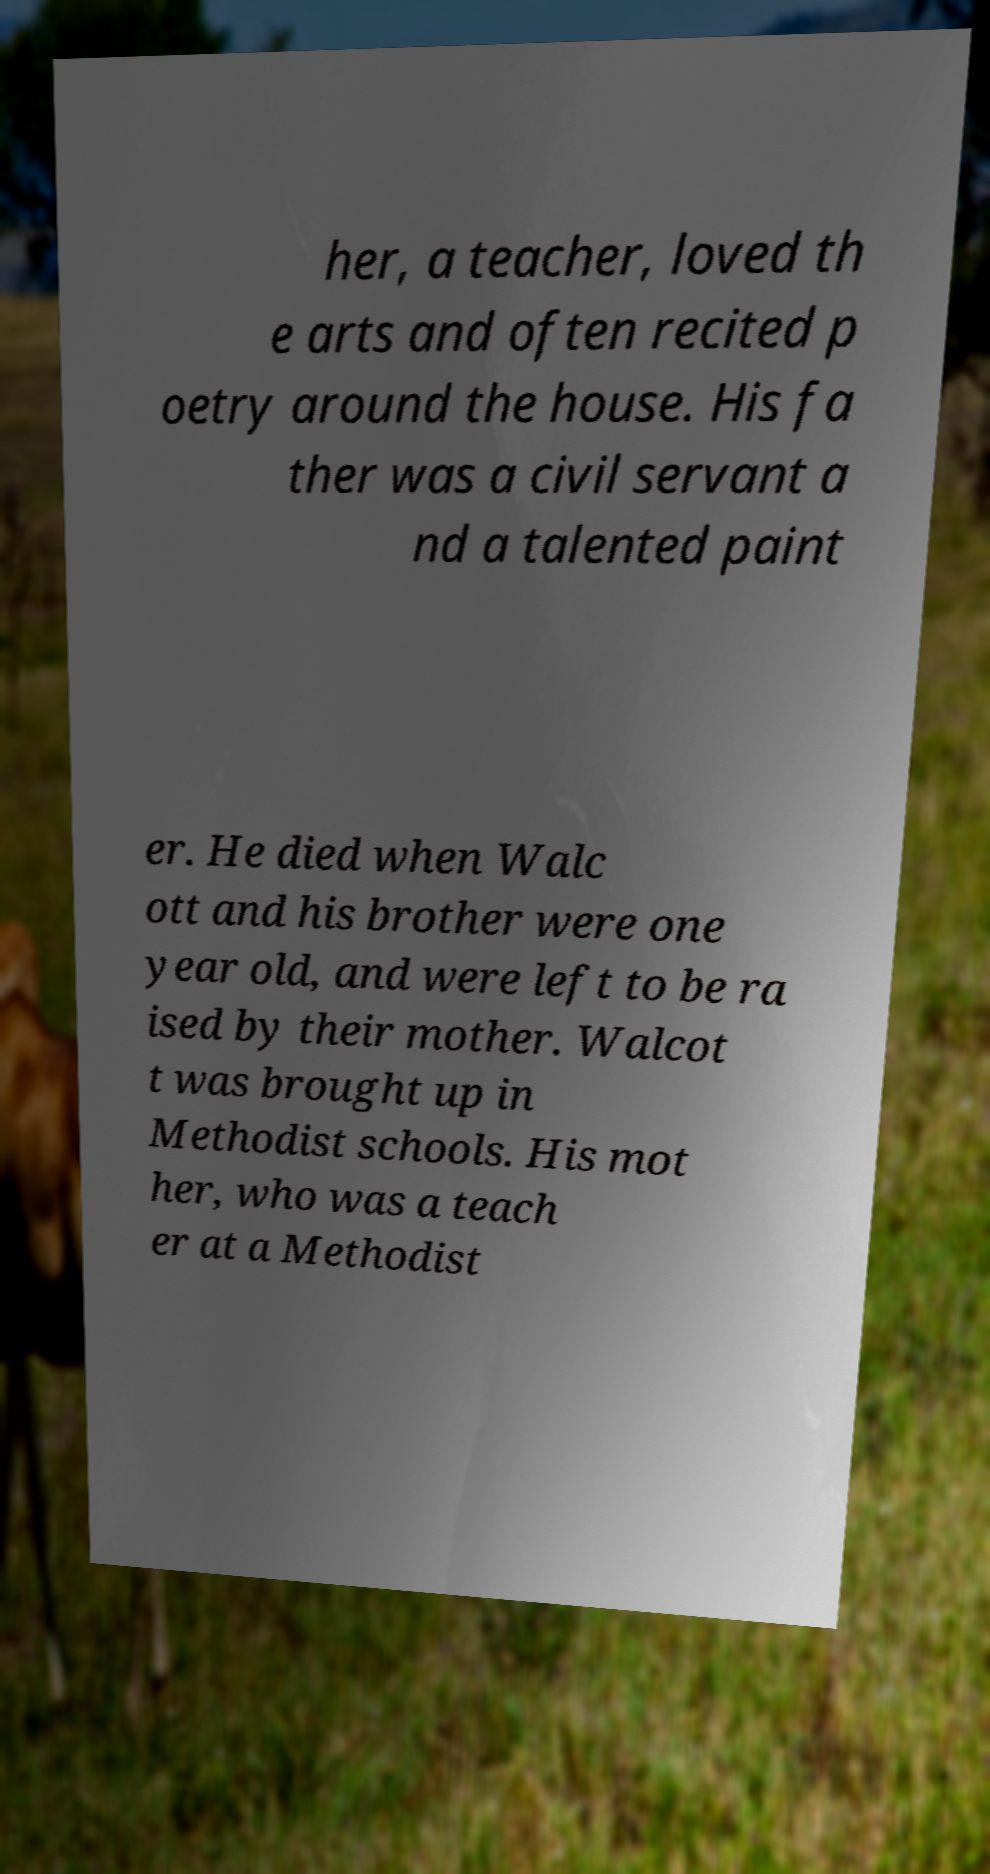Can you accurately transcribe the text from the provided image for me? her, a teacher, loved th e arts and often recited p oetry around the house. His fa ther was a civil servant a nd a talented paint er. He died when Walc ott and his brother were one year old, and were left to be ra ised by their mother. Walcot t was brought up in Methodist schools. His mot her, who was a teach er at a Methodist 